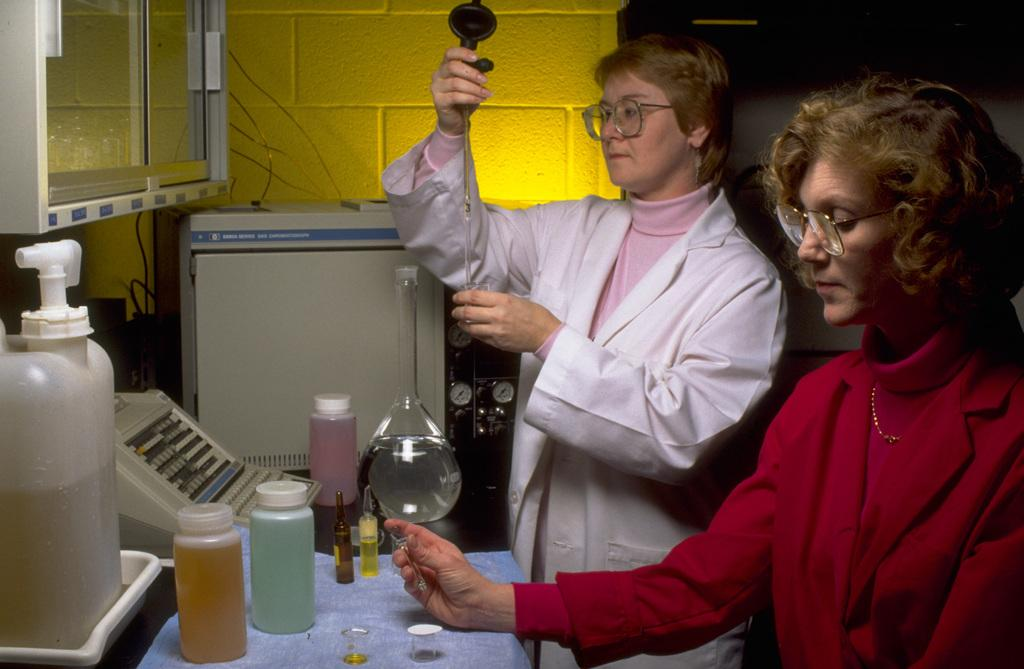Who is present in the image? There is a man and a woman in the image. Where are they located? They are at a laboratory. What type of cherries can be seen on the collar of the man in the image? There are no cherries or collars present in the image. 